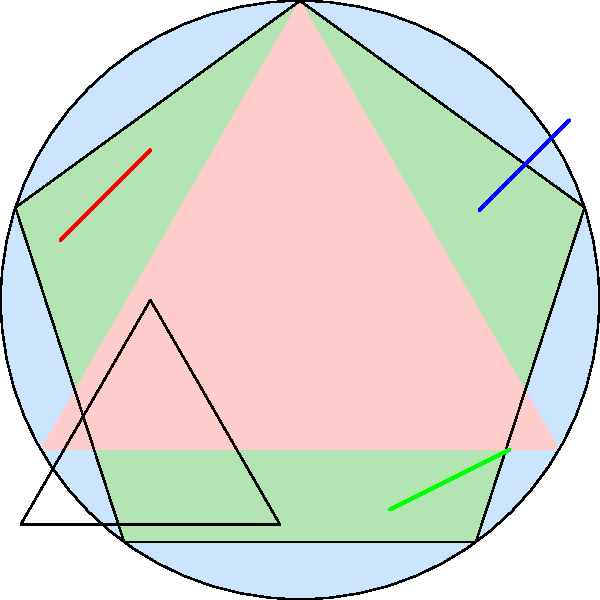In this abstract representation of a natural landscape, how many distinct geometric shapes can you identify? To identify the distinct geometric shapes in this abstract natural scene, let's break it down step-by-step:

1. The largest shape in the background is a circle, representing perhaps a sun or moon in the landscape.

2. Overlapping the circle is a pentagon (a 5-sided polygon), which could be interpreted as a stylized mountain or rock formation.

3. In the lower left quadrant, there's a small triangle, possibly representing a smaller geological feature or vegetation.

4. Apart from these clear geometric shapes, there are three distinct line segments:
   a. A blue line in the upper right quadrant
   b. A green line in the lower right quadrant
   c. A red line in the upper left quadrant

These lines could represent abstract elements like wind, water, or other natural forces in the landscape.

In total, we can identify 6 distinct geometric shapes: 3 polygons (circle, pentagon, triangle) and 3 line segments.
Answer: 6 